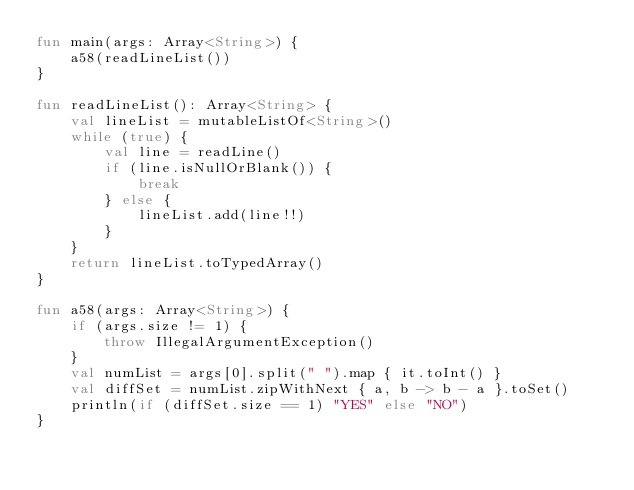<code> <loc_0><loc_0><loc_500><loc_500><_Kotlin_>fun main(args: Array<String>) {
    a58(readLineList())
}

fun readLineList(): Array<String> {
    val lineList = mutableListOf<String>()
    while (true) {
        val line = readLine()
        if (line.isNullOrBlank()) {
            break
        } else {
            lineList.add(line!!)
        }
    }
    return lineList.toTypedArray()
}

fun a58(args: Array<String>) {
    if (args.size != 1) {
        throw IllegalArgumentException()
    }
    val numList = args[0].split(" ").map { it.toInt() }
    val diffSet = numList.zipWithNext { a, b -> b - a }.toSet()
    println(if (diffSet.size == 1) "YES" else "NO")
}
</code> 